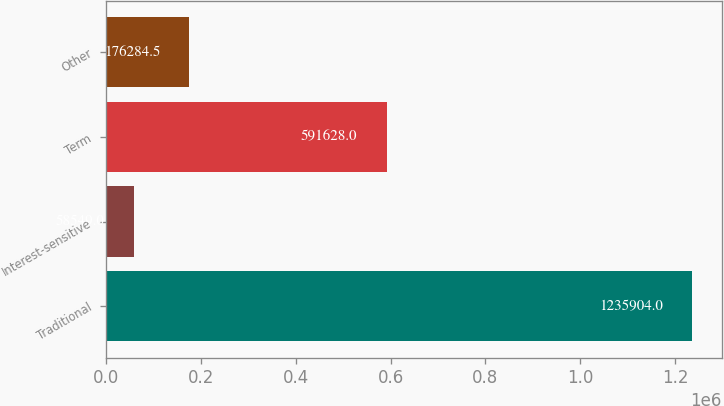<chart> <loc_0><loc_0><loc_500><loc_500><bar_chart><fcel>Traditional<fcel>Interest-sensitive<fcel>Term<fcel>Other<nl><fcel>1.2359e+06<fcel>58549<fcel>591628<fcel>176284<nl></chart> 